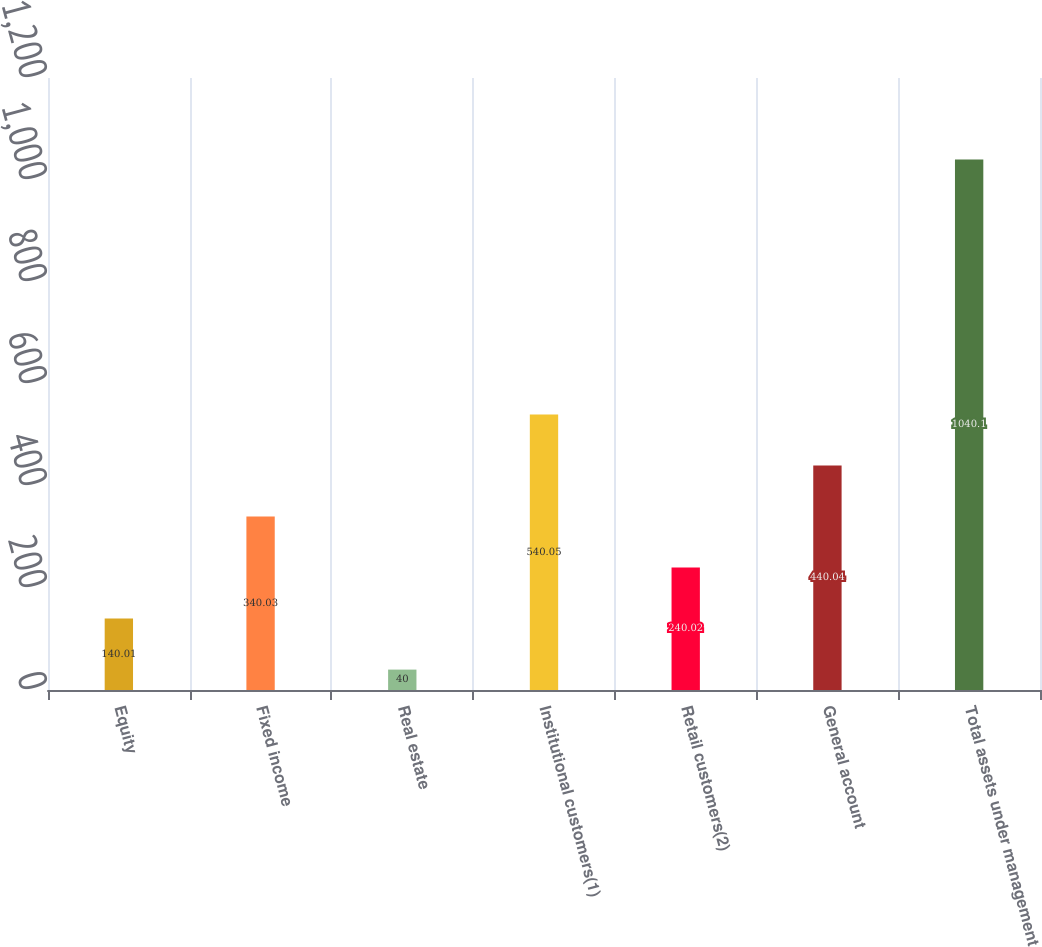Convert chart to OTSL. <chart><loc_0><loc_0><loc_500><loc_500><bar_chart><fcel>Equity<fcel>Fixed income<fcel>Real estate<fcel>Institutional customers(1)<fcel>Retail customers(2)<fcel>General account<fcel>Total assets under management<nl><fcel>140.01<fcel>340.03<fcel>40<fcel>540.05<fcel>240.02<fcel>440.04<fcel>1040.1<nl></chart> 